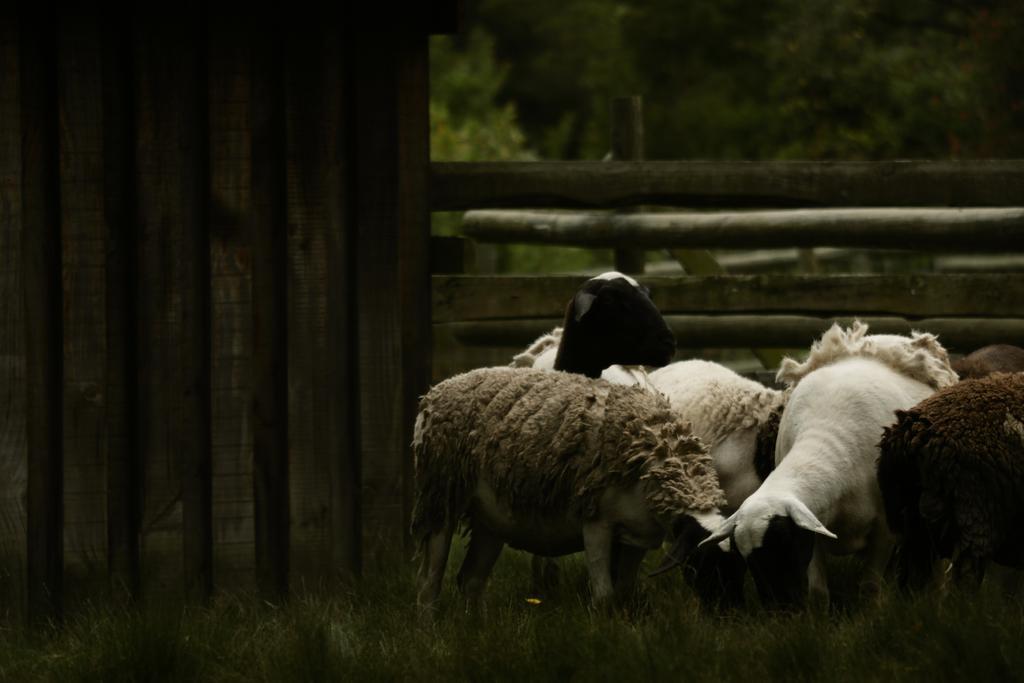Can you describe this image briefly? In this image we can see group of goats on the ground, there are the trees, there is the fencing, here is the grass. 